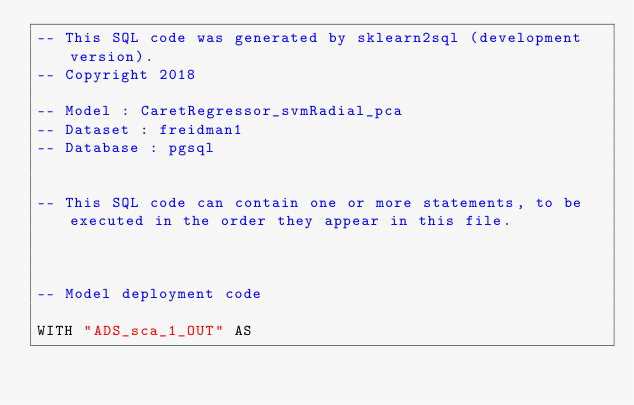Convert code to text. <code><loc_0><loc_0><loc_500><loc_500><_SQL_>-- This SQL code was generated by sklearn2sql (development version).
-- Copyright 2018

-- Model : CaretRegressor_svmRadial_pca
-- Dataset : freidman1
-- Database : pgsql


-- This SQL code can contain one or more statements, to be executed in the order they appear in this file.



-- Model deployment code

WITH "ADS_sca_1_OUT" AS </code> 